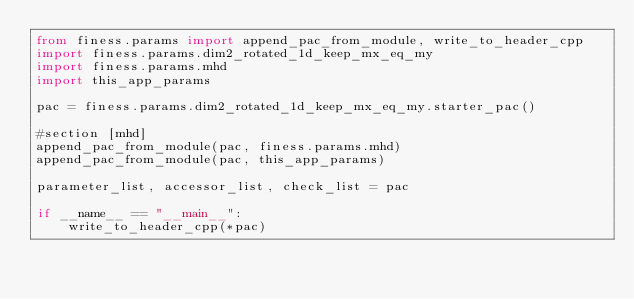<code> <loc_0><loc_0><loc_500><loc_500><_Python_>from finess.params import append_pac_from_module, write_to_header_cpp
import finess.params.dim2_rotated_1d_keep_mx_eq_my
import finess.params.mhd
import this_app_params

pac = finess.params.dim2_rotated_1d_keep_mx_eq_my.starter_pac()

#section [mhd]
append_pac_from_module(pac, finess.params.mhd)
append_pac_from_module(pac, this_app_params)

parameter_list, accessor_list, check_list = pac

if __name__ == "__main__":
    write_to_header_cpp(*pac)




</code> 